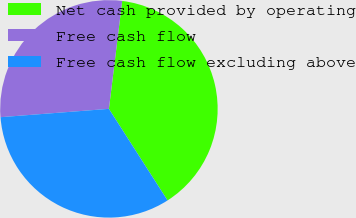<chart> <loc_0><loc_0><loc_500><loc_500><pie_chart><fcel>Net cash provided by operating<fcel>Free cash flow<fcel>Free cash flow excluding above<nl><fcel>38.98%<fcel>28.17%<fcel>32.84%<nl></chart> 